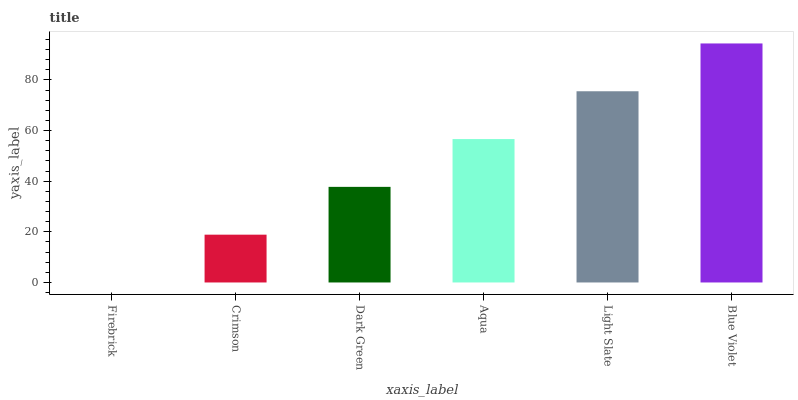Is Firebrick the minimum?
Answer yes or no. Yes. Is Blue Violet the maximum?
Answer yes or no. Yes. Is Crimson the minimum?
Answer yes or no. No. Is Crimson the maximum?
Answer yes or no. No. Is Crimson greater than Firebrick?
Answer yes or no. Yes. Is Firebrick less than Crimson?
Answer yes or no. Yes. Is Firebrick greater than Crimson?
Answer yes or no. No. Is Crimson less than Firebrick?
Answer yes or no. No. Is Aqua the high median?
Answer yes or no. Yes. Is Dark Green the low median?
Answer yes or no. Yes. Is Crimson the high median?
Answer yes or no. No. Is Light Slate the low median?
Answer yes or no. No. 